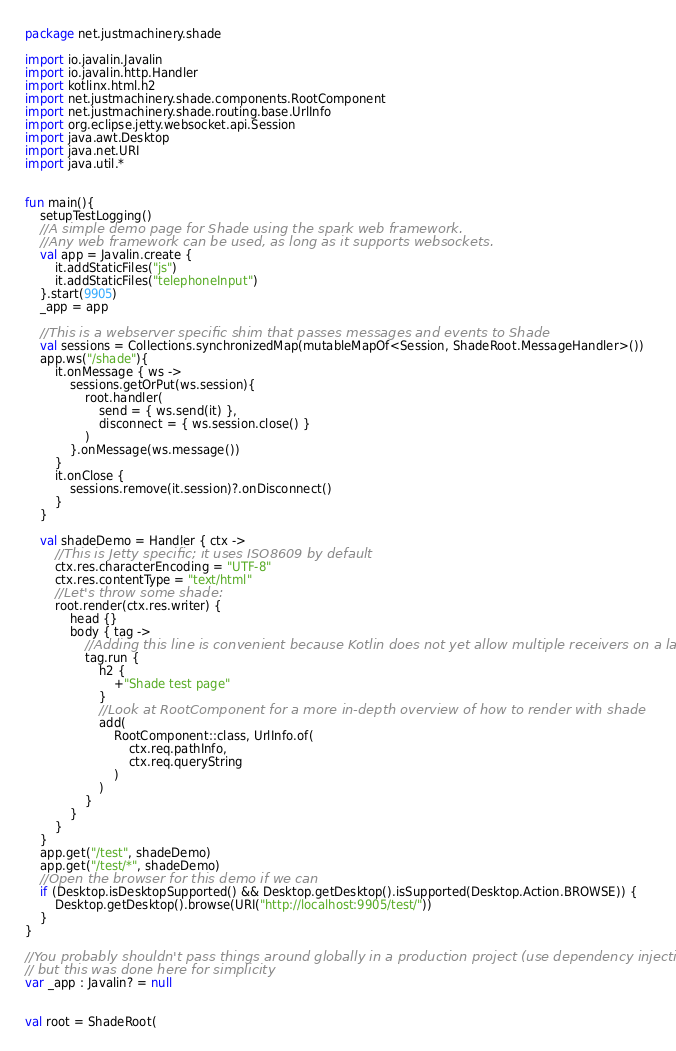Convert code to text. <code><loc_0><loc_0><loc_500><loc_500><_Kotlin_>package net.justmachinery.shade

import io.javalin.Javalin
import io.javalin.http.Handler
import kotlinx.html.h2
import net.justmachinery.shade.components.RootComponent
import net.justmachinery.shade.routing.base.UrlInfo
import org.eclipse.jetty.websocket.api.Session
import java.awt.Desktop
import java.net.URI
import java.util.*


fun main(){
    setupTestLogging()
    //A simple demo page for Shade using the spark web framework.
    //Any web framework can be used, as long as it supports websockets.
    val app = Javalin.create {
        it.addStaticFiles("js")
        it.addStaticFiles("telephoneInput")
    }.start(9905)
    _app = app

    //This is a webserver specific shim that passes messages and events to Shade
    val sessions = Collections.synchronizedMap(mutableMapOf<Session, ShadeRoot.MessageHandler>())
    app.ws("/shade"){
        it.onMessage { ws ->
            sessions.getOrPut(ws.session){
                root.handler(
                    send = { ws.send(it) },
                    disconnect = { ws.session.close() }
                )
            }.onMessage(ws.message())
        }
        it.onClose {
            sessions.remove(it.session)?.onDisconnect()
        }
    }

    val shadeDemo = Handler { ctx ->
        //This is Jetty specific; it uses ISO8609 by default
        ctx.res.characterEncoding = "UTF-8"
        ctx.res.contentType = "text/html"
        //Let's throw some shade:
        root.render(ctx.res.writer) {
            head {}
            body { tag ->
                //Adding this line is convenient because Kotlin does not yet allow multiple receivers on a lambda
                tag.run {
                    h2 {
                        +"Shade test page"
                    }
                    //Look at RootComponent for a more in-depth overview of how to render with shade
                    add(
                        RootComponent::class, UrlInfo.of(
                            ctx.req.pathInfo,
                            ctx.req.queryString
                        )
                    )
                }
            }
        }
    }
    app.get("/test", shadeDemo)
    app.get("/test/*", shadeDemo)
    //Open the browser for this demo if we can
    if (Desktop.isDesktopSupported() && Desktop.getDesktop().isSupported(Desktop.Action.BROWSE)) {
        Desktop.getDesktop().browse(URI("http://localhost:9905/test/"))
    }
}

//You probably shouldn't pass things around globally in a production project (use dependency injection),
// but this was done here for simplicity
var _app : Javalin? = null


val root = ShadeRoot(</code> 